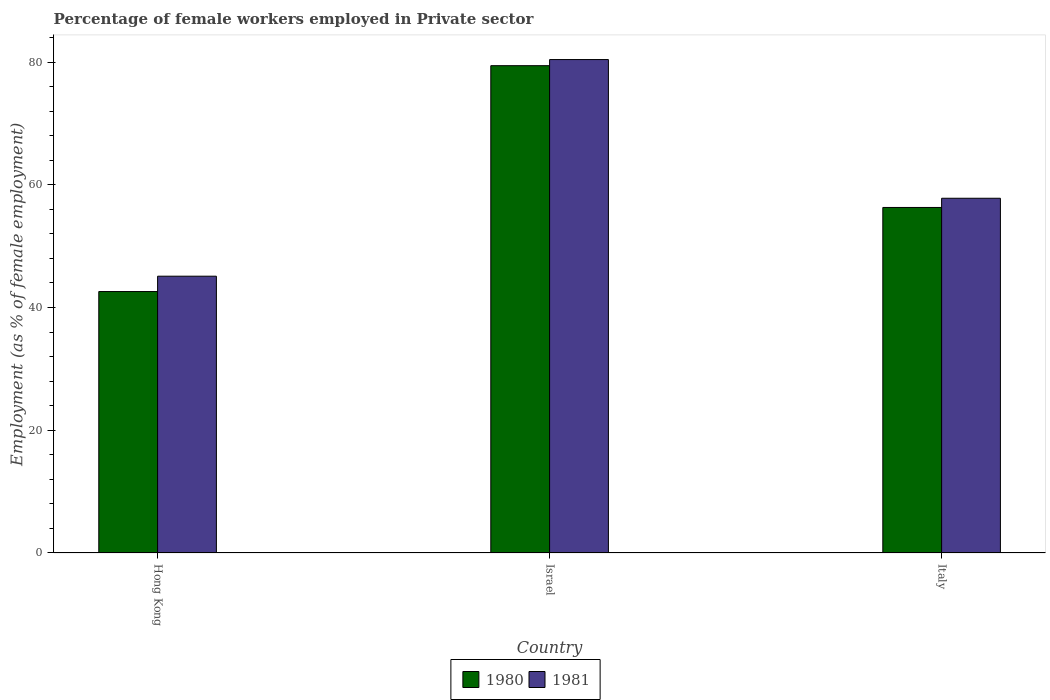Are the number of bars per tick equal to the number of legend labels?
Your answer should be compact. Yes. How many bars are there on the 1st tick from the left?
Your response must be concise. 2. What is the percentage of females employed in Private sector in 1981 in Italy?
Provide a short and direct response. 57.8. Across all countries, what is the maximum percentage of females employed in Private sector in 1981?
Keep it short and to the point. 80.4. Across all countries, what is the minimum percentage of females employed in Private sector in 1980?
Offer a very short reply. 42.6. In which country was the percentage of females employed in Private sector in 1981 maximum?
Provide a succinct answer. Israel. In which country was the percentage of females employed in Private sector in 1981 minimum?
Offer a very short reply. Hong Kong. What is the total percentage of females employed in Private sector in 1980 in the graph?
Your answer should be compact. 178.3. What is the difference between the percentage of females employed in Private sector in 1981 in Hong Kong and that in Italy?
Ensure brevity in your answer.  -12.7. What is the difference between the percentage of females employed in Private sector in 1980 in Israel and the percentage of females employed in Private sector in 1981 in Italy?
Your response must be concise. 21.6. What is the average percentage of females employed in Private sector in 1980 per country?
Make the answer very short. 59.43. What is the difference between the percentage of females employed in Private sector of/in 1981 and percentage of females employed in Private sector of/in 1980 in Israel?
Provide a succinct answer. 1. What is the ratio of the percentage of females employed in Private sector in 1981 in Hong Kong to that in Israel?
Your answer should be compact. 0.56. Is the percentage of females employed in Private sector in 1980 in Hong Kong less than that in Israel?
Your response must be concise. Yes. Is the difference between the percentage of females employed in Private sector in 1981 in Hong Kong and Italy greater than the difference between the percentage of females employed in Private sector in 1980 in Hong Kong and Italy?
Provide a succinct answer. Yes. What is the difference between the highest and the second highest percentage of females employed in Private sector in 1980?
Ensure brevity in your answer.  13.7. What is the difference between the highest and the lowest percentage of females employed in Private sector in 1981?
Your response must be concise. 35.3. Is the sum of the percentage of females employed in Private sector in 1980 in Hong Kong and Israel greater than the maximum percentage of females employed in Private sector in 1981 across all countries?
Offer a terse response. Yes. Where does the legend appear in the graph?
Offer a very short reply. Bottom center. How are the legend labels stacked?
Provide a succinct answer. Horizontal. What is the title of the graph?
Keep it short and to the point. Percentage of female workers employed in Private sector. Does "1998" appear as one of the legend labels in the graph?
Make the answer very short. No. What is the label or title of the Y-axis?
Make the answer very short. Employment (as % of female employment). What is the Employment (as % of female employment) of 1980 in Hong Kong?
Offer a terse response. 42.6. What is the Employment (as % of female employment) in 1981 in Hong Kong?
Make the answer very short. 45.1. What is the Employment (as % of female employment) of 1980 in Israel?
Your response must be concise. 79.4. What is the Employment (as % of female employment) of 1981 in Israel?
Provide a succinct answer. 80.4. What is the Employment (as % of female employment) in 1980 in Italy?
Offer a very short reply. 56.3. What is the Employment (as % of female employment) of 1981 in Italy?
Keep it short and to the point. 57.8. Across all countries, what is the maximum Employment (as % of female employment) of 1980?
Keep it short and to the point. 79.4. Across all countries, what is the maximum Employment (as % of female employment) of 1981?
Give a very brief answer. 80.4. Across all countries, what is the minimum Employment (as % of female employment) of 1980?
Your answer should be compact. 42.6. Across all countries, what is the minimum Employment (as % of female employment) in 1981?
Your response must be concise. 45.1. What is the total Employment (as % of female employment) in 1980 in the graph?
Your answer should be compact. 178.3. What is the total Employment (as % of female employment) in 1981 in the graph?
Offer a very short reply. 183.3. What is the difference between the Employment (as % of female employment) in 1980 in Hong Kong and that in Israel?
Keep it short and to the point. -36.8. What is the difference between the Employment (as % of female employment) in 1981 in Hong Kong and that in Israel?
Your answer should be very brief. -35.3. What is the difference between the Employment (as % of female employment) in 1980 in Hong Kong and that in Italy?
Make the answer very short. -13.7. What is the difference between the Employment (as % of female employment) in 1980 in Israel and that in Italy?
Offer a very short reply. 23.1. What is the difference between the Employment (as % of female employment) in 1981 in Israel and that in Italy?
Make the answer very short. 22.6. What is the difference between the Employment (as % of female employment) of 1980 in Hong Kong and the Employment (as % of female employment) of 1981 in Israel?
Your answer should be very brief. -37.8. What is the difference between the Employment (as % of female employment) of 1980 in Hong Kong and the Employment (as % of female employment) of 1981 in Italy?
Provide a succinct answer. -15.2. What is the difference between the Employment (as % of female employment) of 1980 in Israel and the Employment (as % of female employment) of 1981 in Italy?
Your answer should be compact. 21.6. What is the average Employment (as % of female employment) of 1980 per country?
Your answer should be very brief. 59.43. What is the average Employment (as % of female employment) of 1981 per country?
Offer a terse response. 61.1. What is the difference between the Employment (as % of female employment) of 1980 and Employment (as % of female employment) of 1981 in Hong Kong?
Keep it short and to the point. -2.5. What is the ratio of the Employment (as % of female employment) in 1980 in Hong Kong to that in Israel?
Ensure brevity in your answer.  0.54. What is the ratio of the Employment (as % of female employment) of 1981 in Hong Kong to that in Israel?
Provide a short and direct response. 0.56. What is the ratio of the Employment (as % of female employment) in 1980 in Hong Kong to that in Italy?
Your answer should be compact. 0.76. What is the ratio of the Employment (as % of female employment) of 1981 in Hong Kong to that in Italy?
Your response must be concise. 0.78. What is the ratio of the Employment (as % of female employment) of 1980 in Israel to that in Italy?
Make the answer very short. 1.41. What is the ratio of the Employment (as % of female employment) in 1981 in Israel to that in Italy?
Ensure brevity in your answer.  1.39. What is the difference between the highest and the second highest Employment (as % of female employment) in 1980?
Make the answer very short. 23.1. What is the difference between the highest and the second highest Employment (as % of female employment) in 1981?
Your response must be concise. 22.6. What is the difference between the highest and the lowest Employment (as % of female employment) in 1980?
Provide a short and direct response. 36.8. What is the difference between the highest and the lowest Employment (as % of female employment) in 1981?
Offer a very short reply. 35.3. 